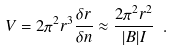Convert formula to latex. <formula><loc_0><loc_0><loc_500><loc_500>V = 2 \pi ^ { 2 } r ^ { 3 } \frac { \delta r } { \delta n } \approx \frac { 2 \pi ^ { 2 } r ^ { 2 } } { | B | I } \ .</formula> 